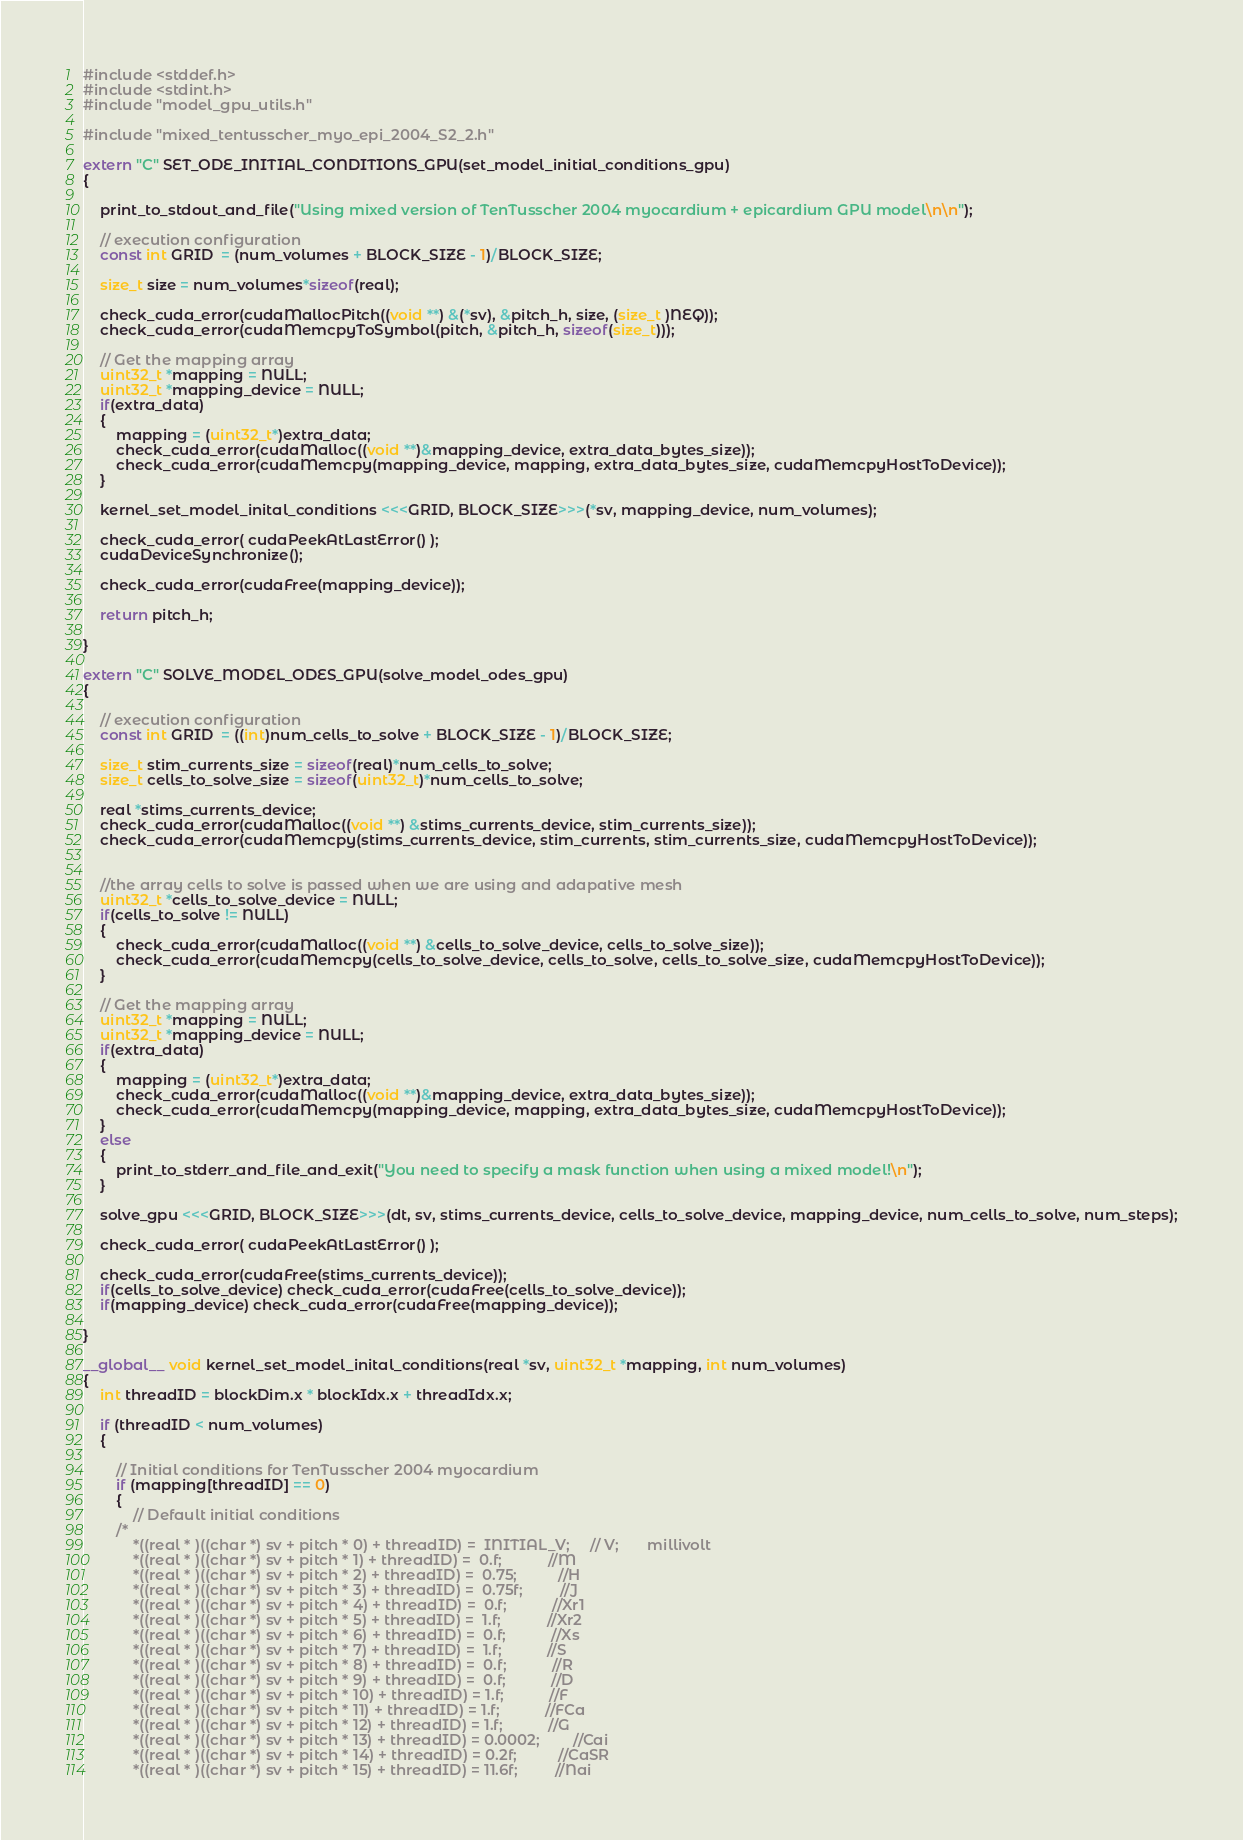<code> <loc_0><loc_0><loc_500><loc_500><_Cuda_>#include <stddef.h>
#include <stdint.h>
#include "model_gpu_utils.h"

#include "mixed_tentusscher_myo_epi_2004_S2_2.h"

extern "C" SET_ODE_INITIAL_CONDITIONS_GPU(set_model_initial_conditions_gpu) 
{

    print_to_stdout_and_file("Using mixed version of TenTusscher 2004 myocardium + epicardium GPU model\n\n");

    // execution configuration
    const int GRID  = (num_volumes + BLOCK_SIZE - 1)/BLOCK_SIZE;

    size_t size = num_volumes*sizeof(real);

    check_cuda_error(cudaMallocPitch((void **) &(*sv), &pitch_h, size, (size_t )NEQ));
    check_cuda_error(cudaMemcpyToSymbol(pitch, &pitch_h, sizeof(size_t)));

    // Get the mapping array
    uint32_t *mapping = NULL;
    uint32_t *mapping_device = NULL;
    if(extra_data) 
    {
        mapping = (uint32_t*)extra_data;
        check_cuda_error(cudaMalloc((void **)&mapping_device, extra_data_bytes_size));
        check_cuda_error(cudaMemcpy(mapping_device, mapping, extra_data_bytes_size, cudaMemcpyHostToDevice));
    }

    kernel_set_model_inital_conditions <<<GRID, BLOCK_SIZE>>>(*sv, mapping_device, num_volumes);

    check_cuda_error( cudaPeekAtLastError() );
    cudaDeviceSynchronize();
    
    check_cuda_error(cudaFree(mapping_device));

    return pitch_h;

}

extern "C" SOLVE_MODEL_ODES_GPU(solve_model_odes_gpu) 
{

    // execution configuration
    const int GRID  = ((int)num_cells_to_solve + BLOCK_SIZE - 1)/BLOCK_SIZE;

    size_t stim_currents_size = sizeof(real)*num_cells_to_solve;
    size_t cells_to_solve_size = sizeof(uint32_t)*num_cells_to_solve;

    real *stims_currents_device;
    check_cuda_error(cudaMalloc((void **) &stims_currents_device, stim_currents_size));
    check_cuda_error(cudaMemcpy(stims_currents_device, stim_currents, stim_currents_size, cudaMemcpyHostToDevice));


    //the array cells to solve is passed when we are using and adapative mesh
    uint32_t *cells_to_solve_device = NULL;
    if(cells_to_solve != NULL) 
    {
        check_cuda_error(cudaMalloc((void **) &cells_to_solve_device, cells_to_solve_size));
        check_cuda_error(cudaMemcpy(cells_to_solve_device, cells_to_solve, cells_to_solve_size, cudaMemcpyHostToDevice));
    }

    // Get the mapping array
    uint32_t *mapping = NULL;
    uint32_t *mapping_device = NULL;
    if(extra_data) 
    {
        mapping = (uint32_t*)extra_data;
        check_cuda_error(cudaMalloc((void **)&mapping_device, extra_data_bytes_size));
        check_cuda_error(cudaMemcpy(mapping_device, mapping, extra_data_bytes_size, cudaMemcpyHostToDevice));
    }
    else 
    {
        print_to_stderr_and_file_and_exit("You need to specify a mask function when using a mixed model!\n");
    }

    solve_gpu <<<GRID, BLOCK_SIZE>>>(dt, sv, stims_currents_device, cells_to_solve_device, mapping_device, num_cells_to_solve, num_steps);

    check_cuda_error( cudaPeekAtLastError() );

    check_cuda_error(cudaFree(stims_currents_device));
    if(cells_to_solve_device) check_cuda_error(cudaFree(cells_to_solve_device));
    if(mapping_device) check_cuda_error(cudaFree(mapping_device));

}

__global__ void kernel_set_model_inital_conditions(real *sv, uint32_t *mapping, int num_volumes) 
{
    int threadID = blockDim.x * blockIdx.x + threadIdx.x;

    if (threadID < num_volumes) 
    {

        // Initial conditions for TenTusscher 2004 myocardium
        if (mapping[threadID] == 0)
        {
            // Default initial conditions
        /*
            *((real * )((char *) sv + pitch * 0) + threadID) =  INITIAL_V;     // V;       millivolt
            *((real * )((char *) sv + pitch * 1) + threadID) =  0.f;           //M
            *((real * )((char *) sv + pitch * 2) + threadID) =  0.75;          //H
            *((real * )((char *) sv + pitch * 3) + threadID) =  0.75f;         //J
            *((real * )((char *) sv + pitch * 4) + threadID) =  0.f;           //Xr1
            *((real * )((char *) sv + pitch * 5) + threadID) =  1.f;           //Xr2
            *((real * )((char *) sv + pitch * 6) + threadID) =  0.f;           //Xs
            *((real * )((char *) sv + pitch * 7) + threadID) =  1.f;           //S
            *((real * )((char *) sv + pitch * 8) + threadID) =  0.f;           //R
            *((real * )((char *) sv + pitch * 9) + threadID) =  0.f;           //D
            *((real * )((char *) sv + pitch * 10) + threadID) = 1.f;           //F
            *((real * )((char *) sv + pitch * 11) + threadID) = 1.f;           //FCa
            *((real * )((char *) sv + pitch * 12) + threadID) = 1.f;           //G
            *((real * )((char *) sv + pitch * 13) + threadID) = 0.0002;        //Cai
            *((real * )((char *) sv + pitch * 14) + threadID) = 0.2f;          //CaSR
            *((real * )((char *) sv + pitch * 15) + threadID) = 11.6f;         //Nai</code> 